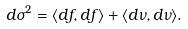<formula> <loc_0><loc_0><loc_500><loc_500>d \sigma ^ { 2 } = \langle d f , d f \rangle + \langle d \nu , d \nu \rangle .</formula> 